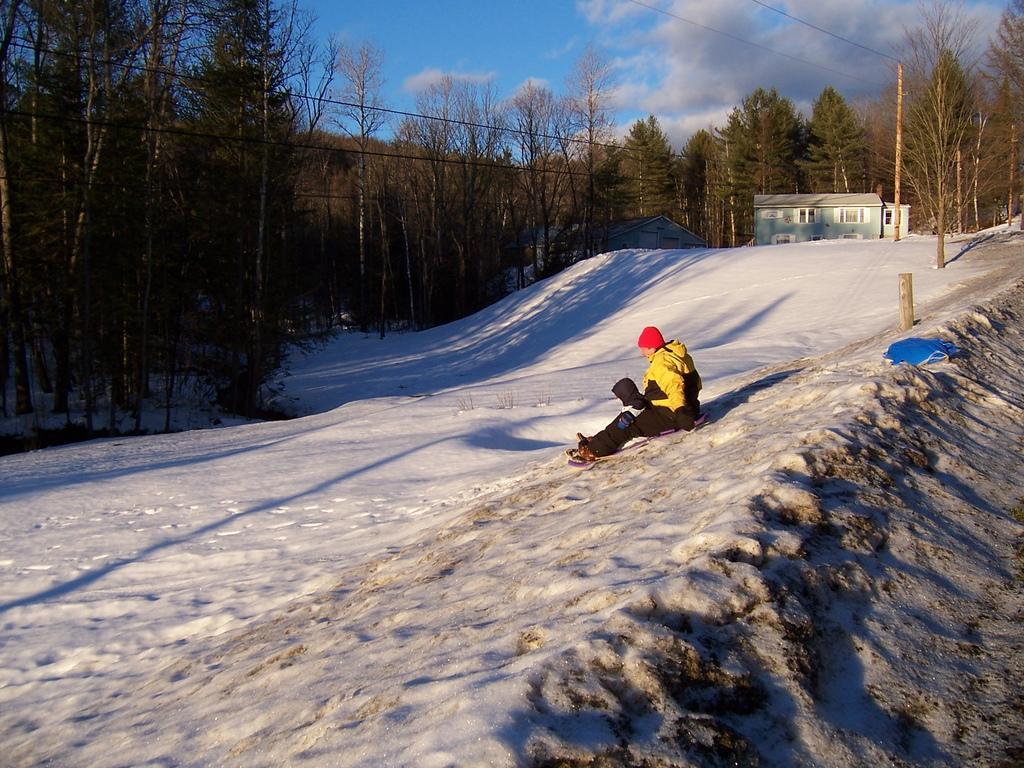Could you give a brief overview of what you see in this image? In this image we can see a person sitting on the snow. We can also see some poles with wires, a group of trees, a house with roof and windows and the sky which looks cloudy. 